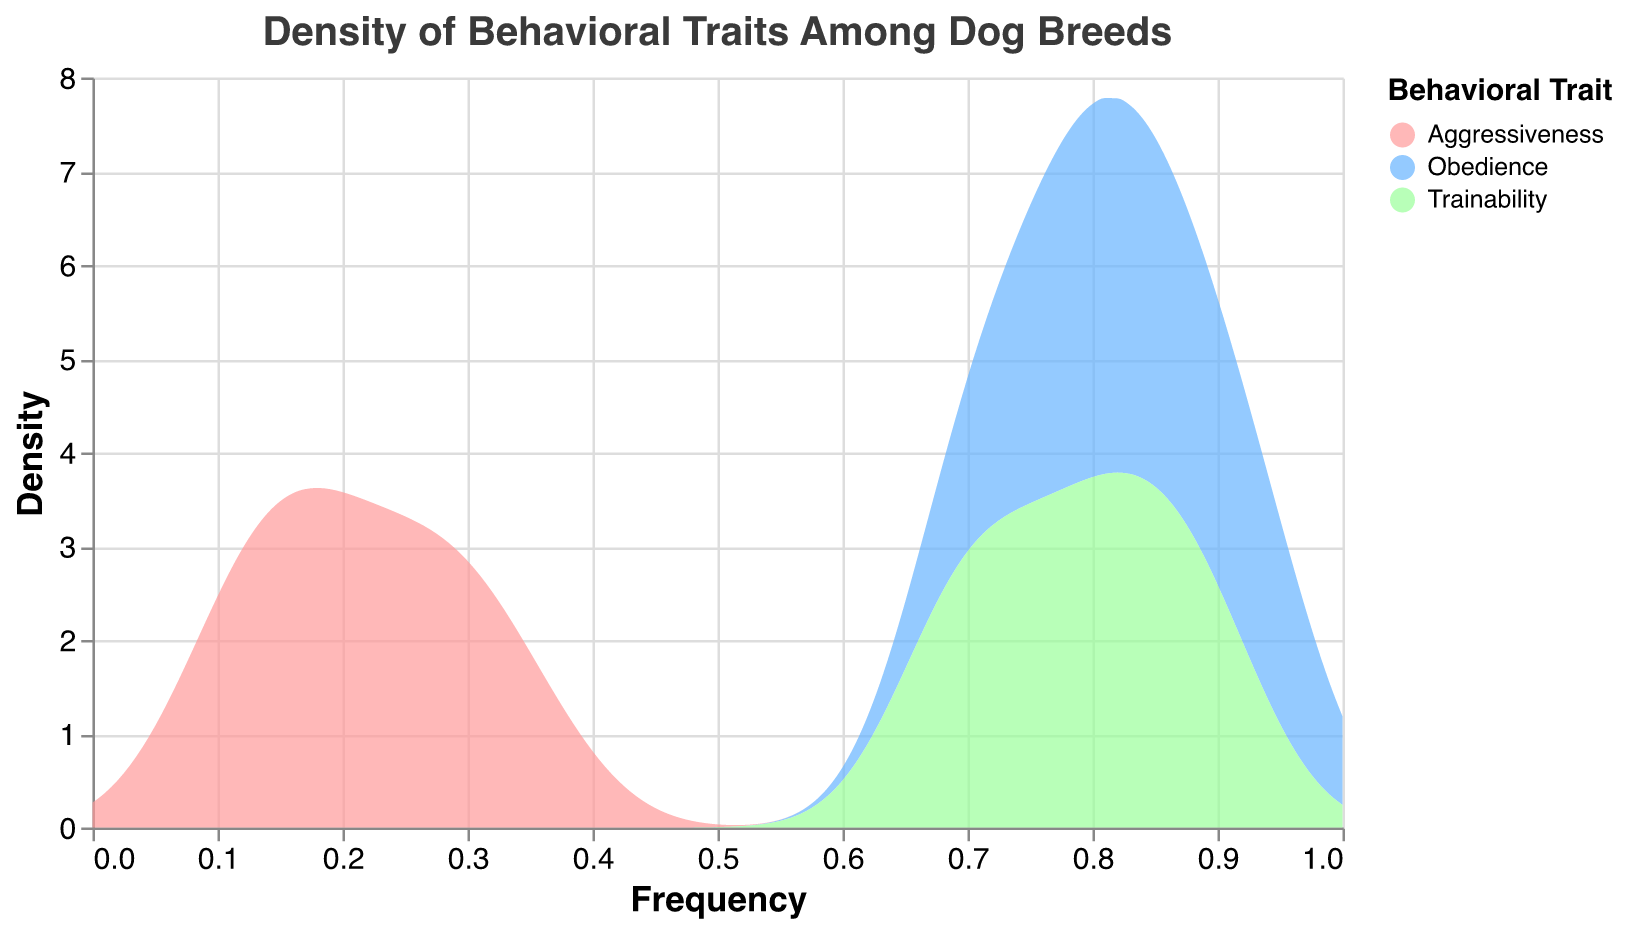What is the title of the plot? The title is prominently displayed at the top of the figure and usually provides a quick overview of the plot's content.
Answer: Density of Behavioral Traits Among Dog Breeds Which axis represents the frequency? The x-axis title indicates it represents frequency.
Answer: x-axis How many behavioral traits are depicted in the plot? The legend on the right side indicates the number of distinct behavioral traits by showing three different colors.
Answer: 3 Which behavioral trait has the highest maximum frequency? Observing the x-axis, the behavioral trait corresponding to the highest frequency value of 0.95 is Obedience, indicated by the associated color.
Answer: Obedience Which behavioral trait has the widest range of frequencies? We need to compare the spread on the x-axis for each trait. Aggressiveness has values ranging from 0.1 to 0.35, while Obedience ranges from 0.7 to 0.95 and Trainability from 0.68 to 0.9. Therefore, the widest range is for Aggressiveness.
Answer: Aggressiveness What is the general trend in the density of Obedience frequency compared to Aggressiveness frequency? By examining the plotting area, densities for Obedience peak at higher frequencies and are more concentrated at higher values. In contrast, Aggressiveness generally shows higher densities at lower frequency values.
Answer: Obedience densities peak at higher frequencies Which dog breed has the lowest trainability frequency? The data shows the frequencies of trainability for different breeds. Comparing these, Yorkshire Terrier has the lowest at 0.68.
Answer: Yorkshire Terrier Compare the median frequency values of Obedience and Trainability traits across the breeds. For median values, we observe the middle value in the frequency ranges for each trait: Obedience (0.7 to 0.95) has a median around 0.825, Trainability (0.68 to 0.9) has a median around 0.79.
Answer: Obedience: 0.825, Trainability: 0.79 What is the least aggressive breed according to the plot? By finding the minimum value in the Aggressiveness trait, Golden Retriever has the lowest frequency at 0.1.
Answer: Golden Retriever 